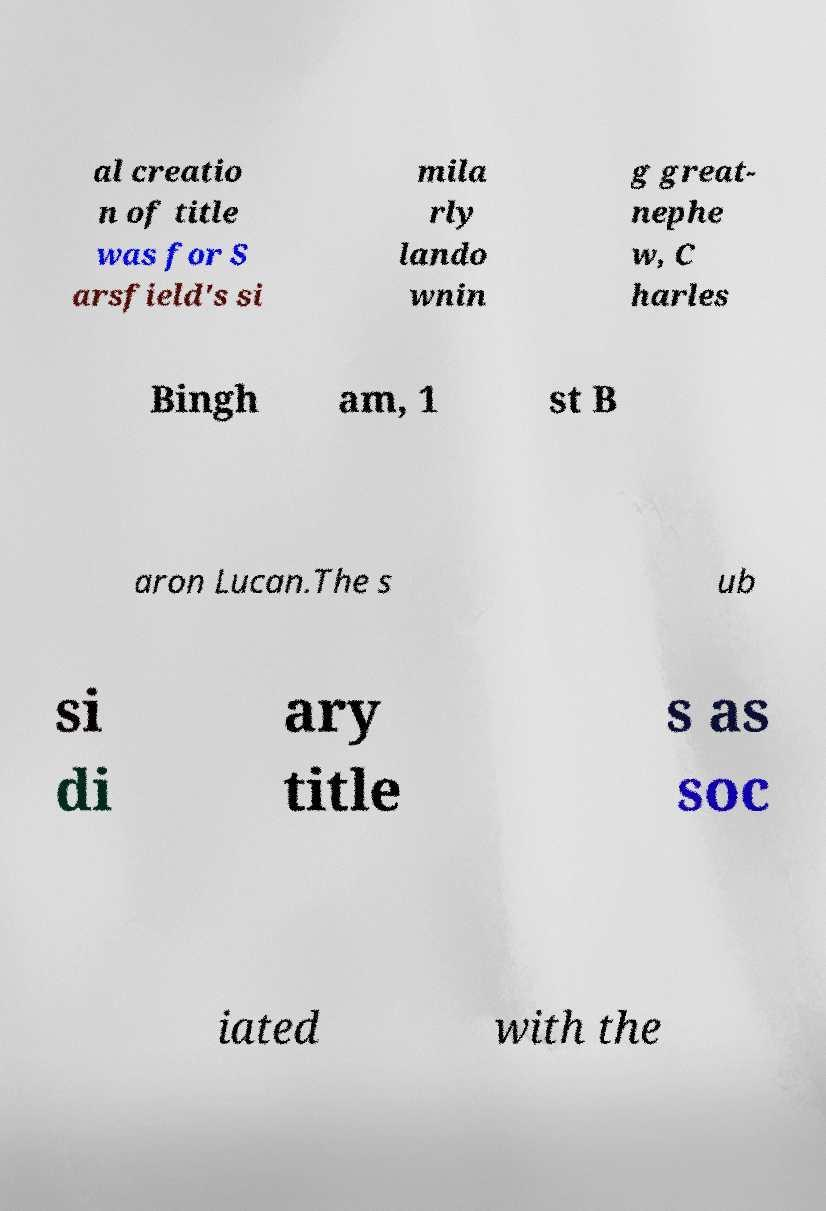Can you accurately transcribe the text from the provided image for me? al creatio n of title was for S arsfield's si mila rly lando wnin g great- nephe w, C harles Bingh am, 1 st B aron Lucan.The s ub si di ary title s as soc iated with the 